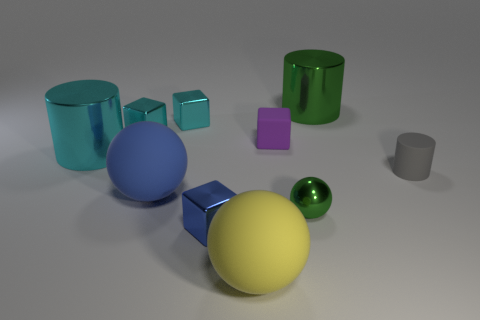What is the color of the large shiny thing on the left side of the large metallic object that is right of the large cyan cylinder?
Your response must be concise. Cyan. Does the small gray thing have the same shape as the tiny matte object that is on the left side of the big green metal cylinder?
Your response must be concise. No. What number of cyan objects are the same size as the yellow object?
Provide a short and direct response. 1. There is a tiny object that is the same shape as the large yellow matte thing; what is it made of?
Offer a very short reply. Metal. There is a metallic block that is in front of the small gray rubber cylinder; does it have the same color as the large matte sphere behind the small green ball?
Make the answer very short. Yes. What shape is the rubber thing in front of the blue shiny block?
Your answer should be very brief. Sphere. The metallic ball is what color?
Your answer should be very brief. Green. There is a large blue object that is the same material as the small purple block; what is its shape?
Provide a short and direct response. Sphere. Do the green thing that is behind the gray rubber object and the large cyan metal cylinder have the same size?
Your answer should be compact. Yes. What number of things are spheres that are in front of the large blue thing or blocks that are to the left of the big yellow object?
Provide a succinct answer. 5. 